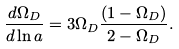<formula> <loc_0><loc_0><loc_500><loc_500>\frac { d \Omega _ { D } } { d \ln a } = 3 \Omega _ { D } \frac { ( 1 - \Omega _ { D } ) } { 2 - \Omega _ { D } } .</formula> 